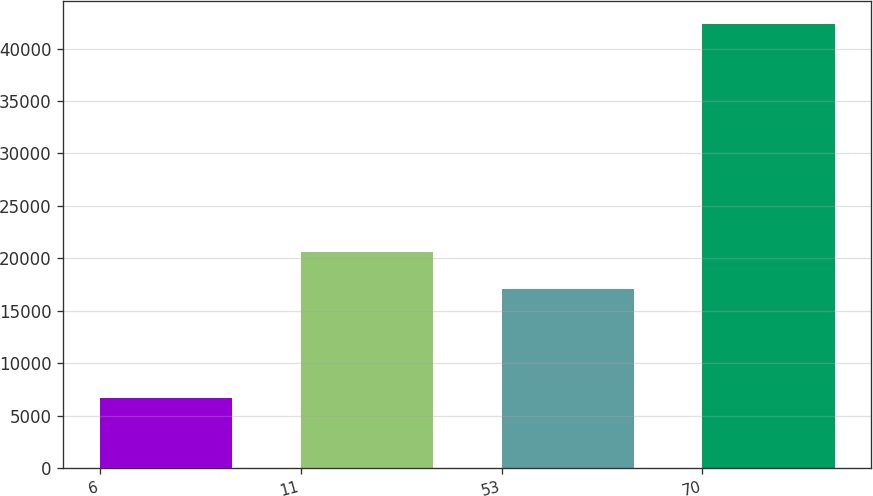<chart> <loc_0><loc_0><loc_500><loc_500><bar_chart><fcel>6<fcel>11<fcel>53<fcel>70<nl><fcel>6708<fcel>20623.9<fcel>17057<fcel>42377<nl></chart> 